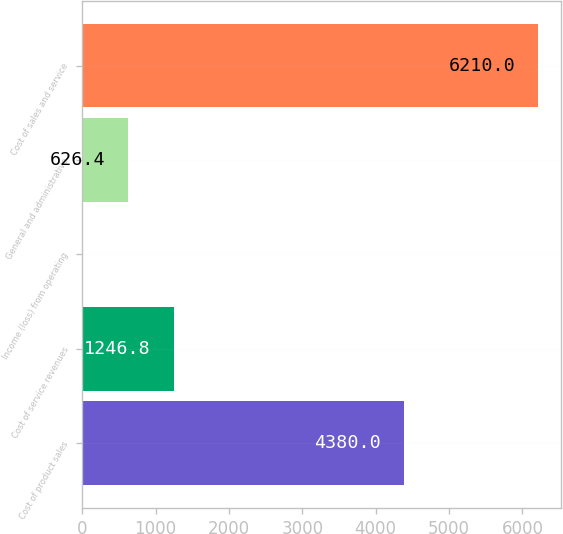Convert chart to OTSL. <chart><loc_0><loc_0><loc_500><loc_500><bar_chart><fcel>Cost of product sales<fcel>Cost of service revenues<fcel>Income (loss) from operating<fcel>General and administrative<fcel>Cost of sales and service<nl><fcel>4380<fcel>1246.8<fcel>6<fcel>626.4<fcel>6210<nl></chart> 